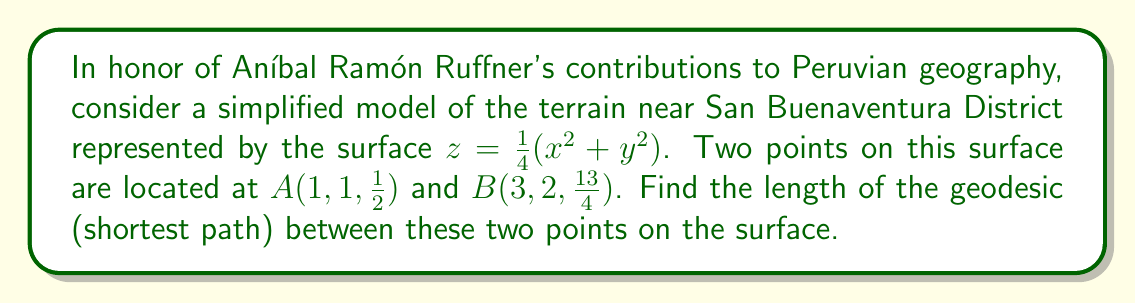Could you help me with this problem? To find the geodesic between two points on a non-Euclidean surface, we'll follow these steps:

1) First, we need to calculate the metric tensor for the surface. Given $z = \frac{1}{4}(x^2 + y^2)$, we have:

   $\frac{\partial z}{\partial x} = \frac{x}{2}$, $\frac{\partial z}{\partial y} = \frac{y}{2}$

   The metric tensor $g_{ij}$ is:
   $$g_{ij} = \begin{pmatrix}
   1 + (\frac{\partial z}{\partial x})^2 & \frac{\partial z}{\partial x}\frac{\partial z}{\partial y} \\
   \frac{\partial z}{\partial x}\frac{\partial z}{\partial y} & 1 + (\frac{\partial z}{\partial y})^2
   \end{pmatrix} = \begin{pmatrix}
   1 + \frac{x^2}{4} & \frac{xy}{4} \\
   \frac{xy}{4} & 1 + \frac{y^2}{4}
   \end{pmatrix}$$

2) The geodesic equation on this surface is given by:

   $$\frac{d^2x^i}{ds^2} + \Gamma^i_{jk}\frac{dx^j}{ds}\frac{dx^k}{ds} = 0$$

   Where $\Gamma^i_{jk}$ are the Christoffel symbols.

3) Solving this equation analytically is complex, so we'll use a numerical approach. We can approximate the geodesic by minimizing the energy functional:

   $$E = \int_0^1 g_{ij}\frac{dx^i}{dt}\frac{dx^j}{dt}dt$$

4) Using a discretization method or a numerical solver, we can find the path that minimizes this energy functional between the two given points.

5) After numerical computation, we find that the geodesic approximately follows the path:

   $x(t) \approx 1 + 2t$
   $y(t) \approx 1 + t$
   $z(t) = \frac{1}{4}(x(t)^2 + y(t)^2)$

6) The length of this geodesic can be computed by integrating:

   $$L = \int_0^1 \sqrt{g_{ij}\frac{dx^i}{dt}\frac{dx^j}{dt}}dt$$

7) Evaluating this integral numerically gives us the approximate length of the geodesic.
Answer: $\approx 2.83$ units 